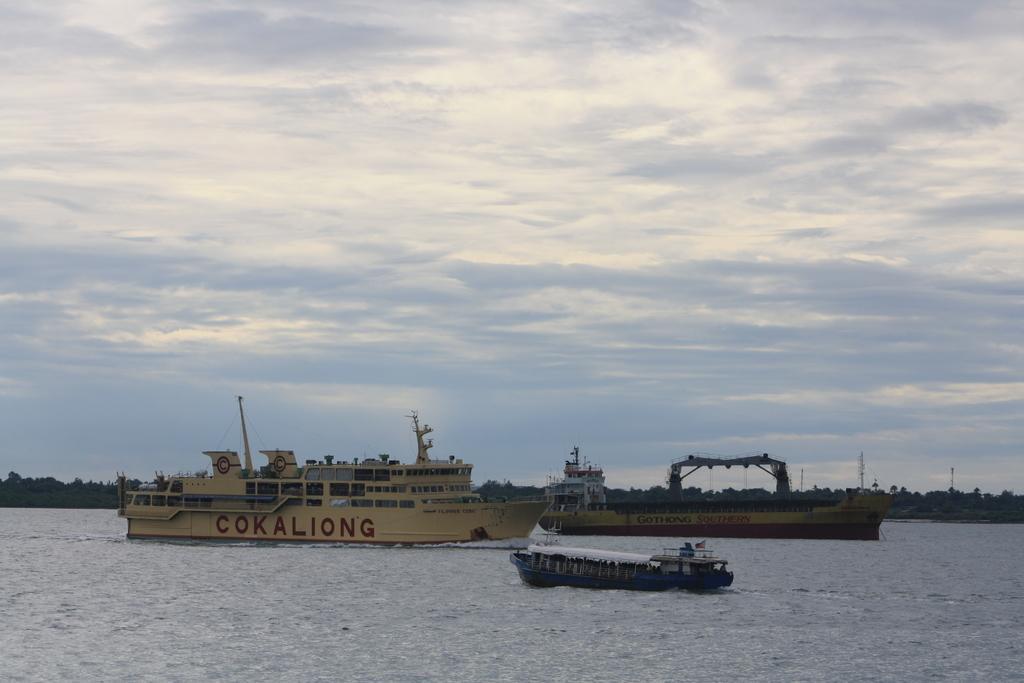Please provide a concise description of this image. In this image there is water. There are ships. There are many trees in the background. There is a building. There is a sky. 